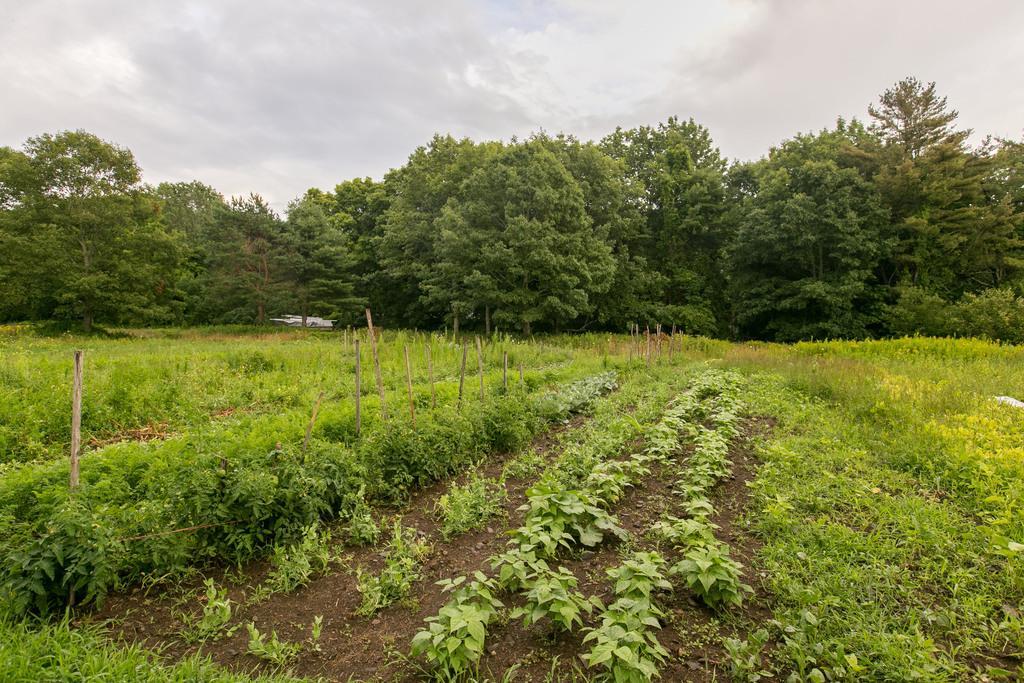Please provide a concise description of this image. In the given image i can see a plants,sand,wooden sticks,trees and in the background i can see the sky. 